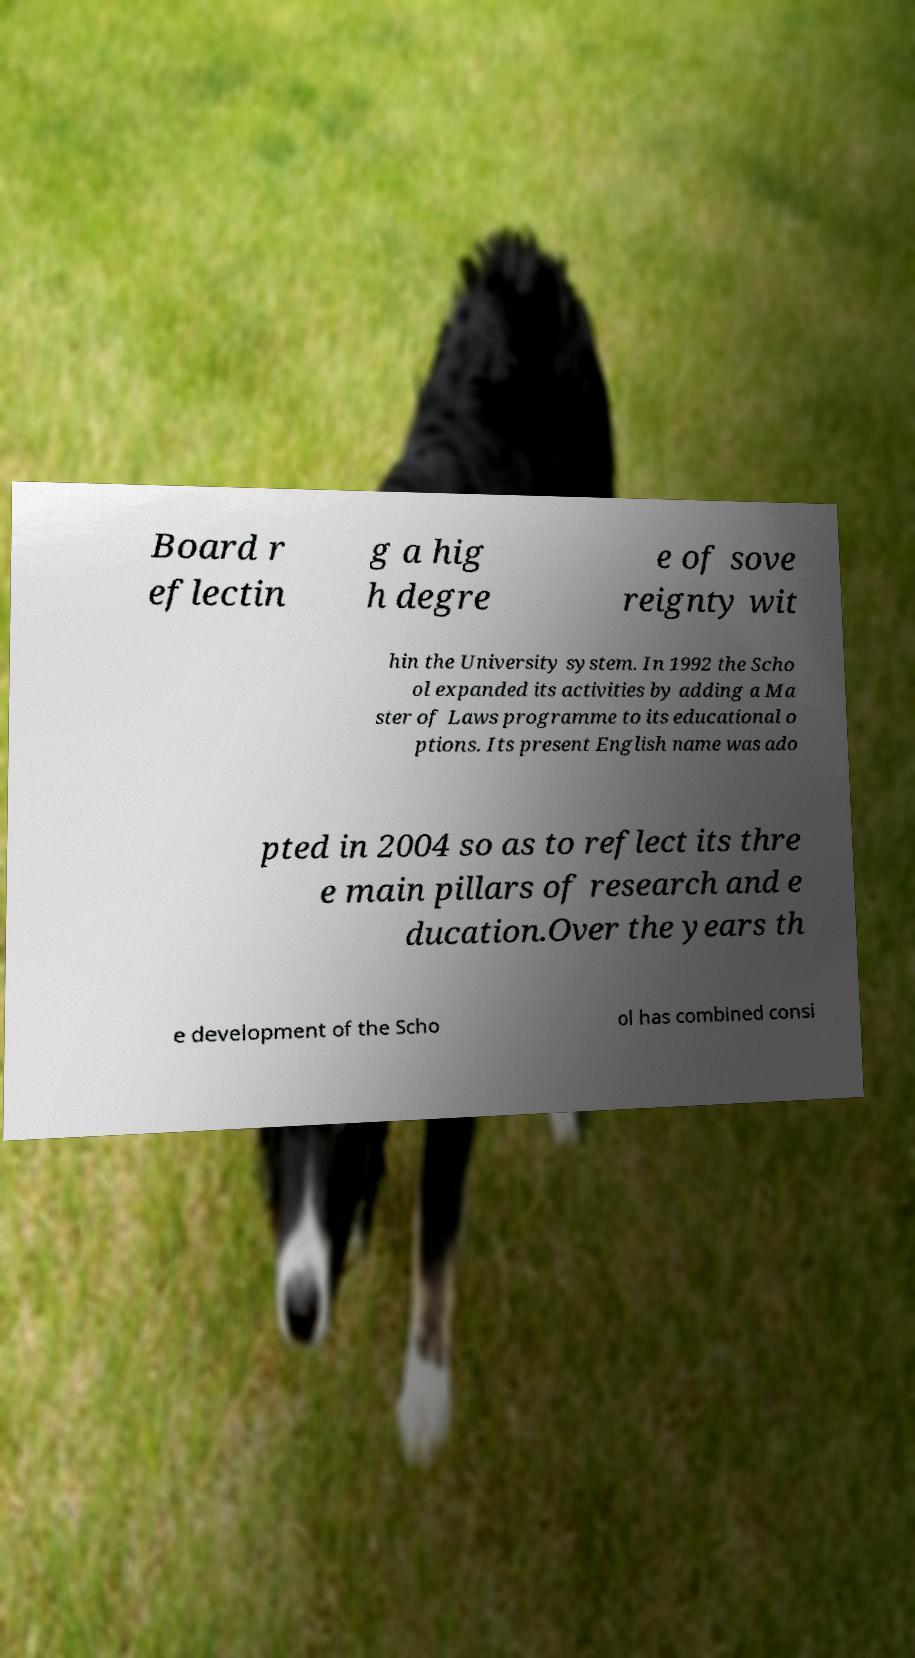Can you read and provide the text displayed in the image?This photo seems to have some interesting text. Can you extract and type it out for me? Board r eflectin g a hig h degre e of sove reignty wit hin the University system. In 1992 the Scho ol expanded its activities by adding a Ma ster of Laws programme to its educational o ptions. Its present English name was ado pted in 2004 so as to reflect its thre e main pillars of research and e ducation.Over the years th e development of the Scho ol has combined consi 